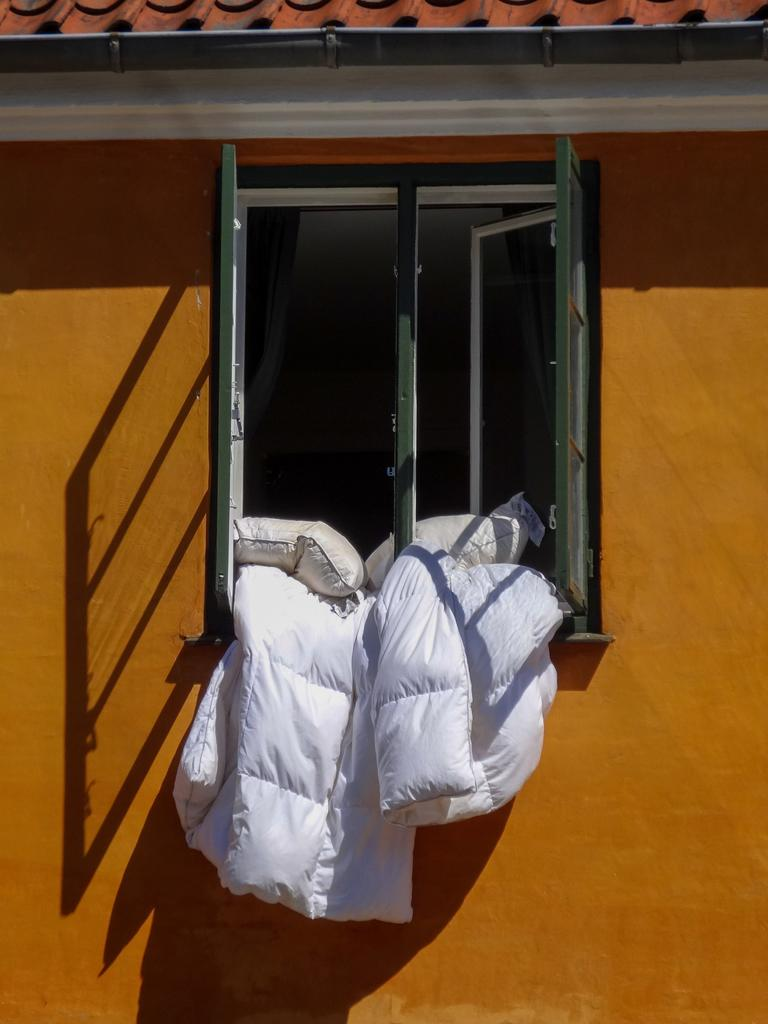What type of structure is visible in the image? There is a wall and a roof visible in the image. What architectural features can be seen on the wall? There are windows visible on the wall. What type of furniture or accessories can be seen in the image? There are pillows and a blanket visible in the image. What type of skirt is being used as a curtain for the windows in the image? There is no skirt present in the image, nor is it being used as a curtain for the windows. 